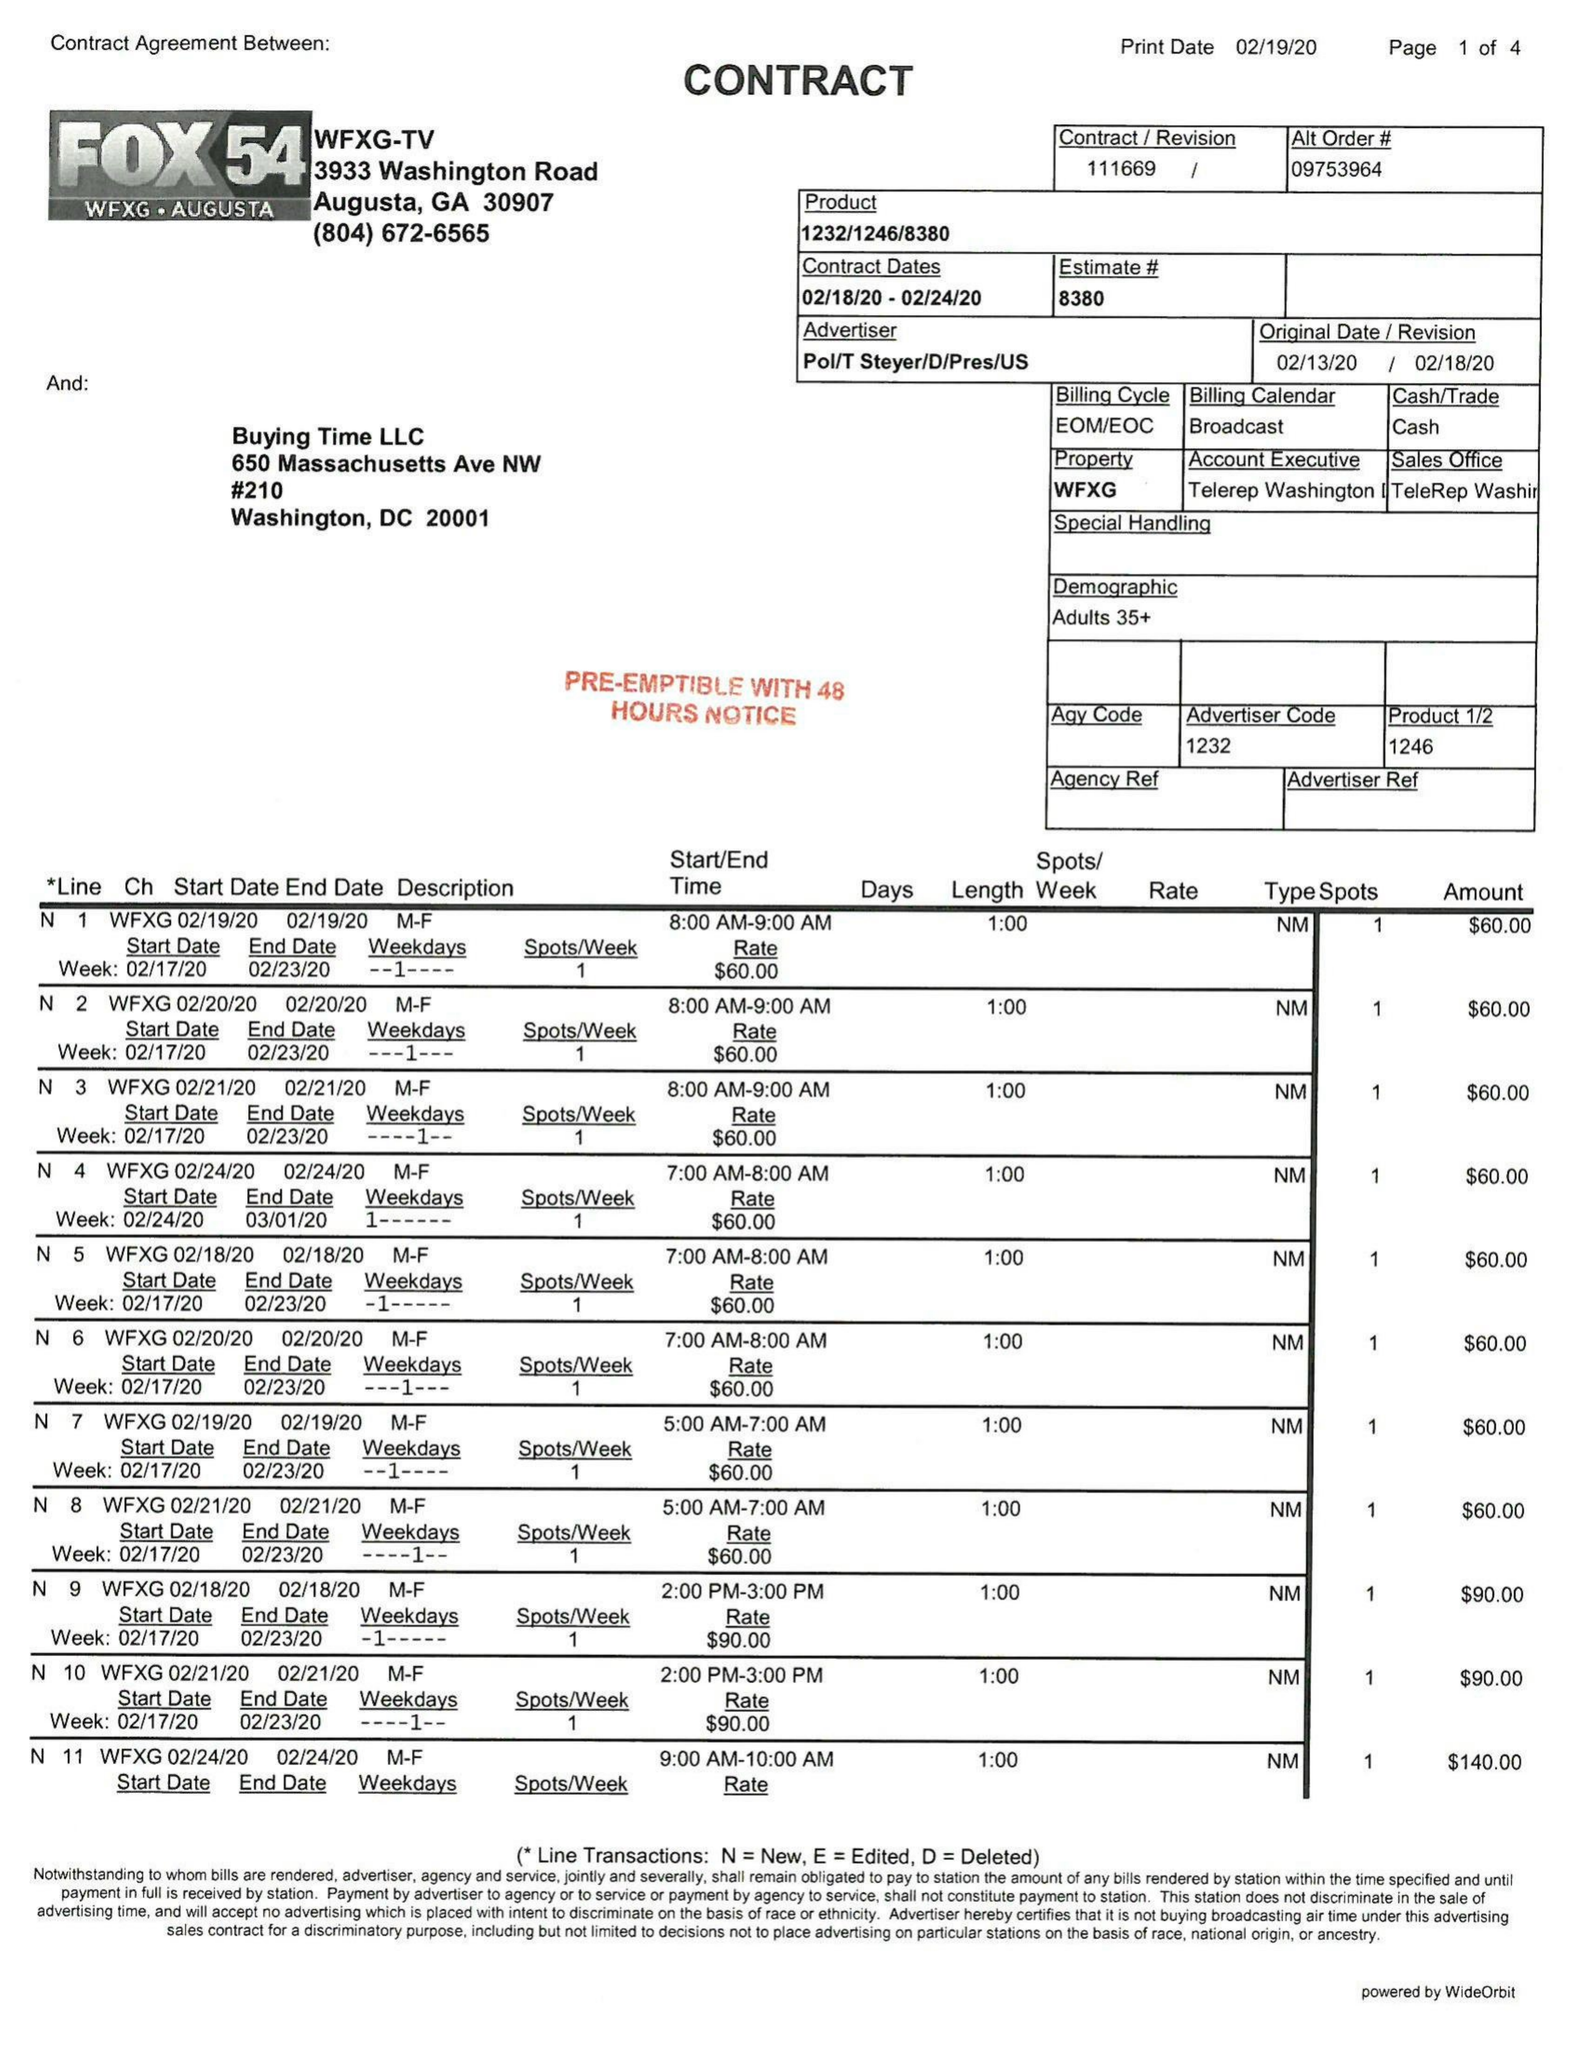What is the value for the gross_amount?
Answer the question using a single word or phrase. 7410.00 